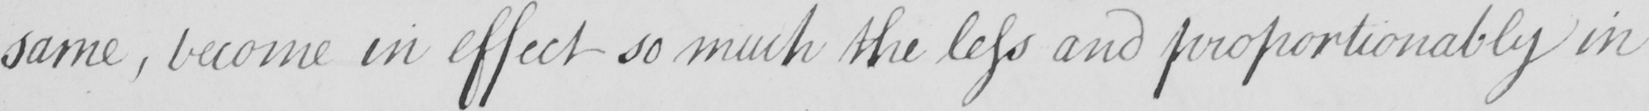Please provide the text content of this handwritten line. same , become in effect so much the less and proportionably insufficient 